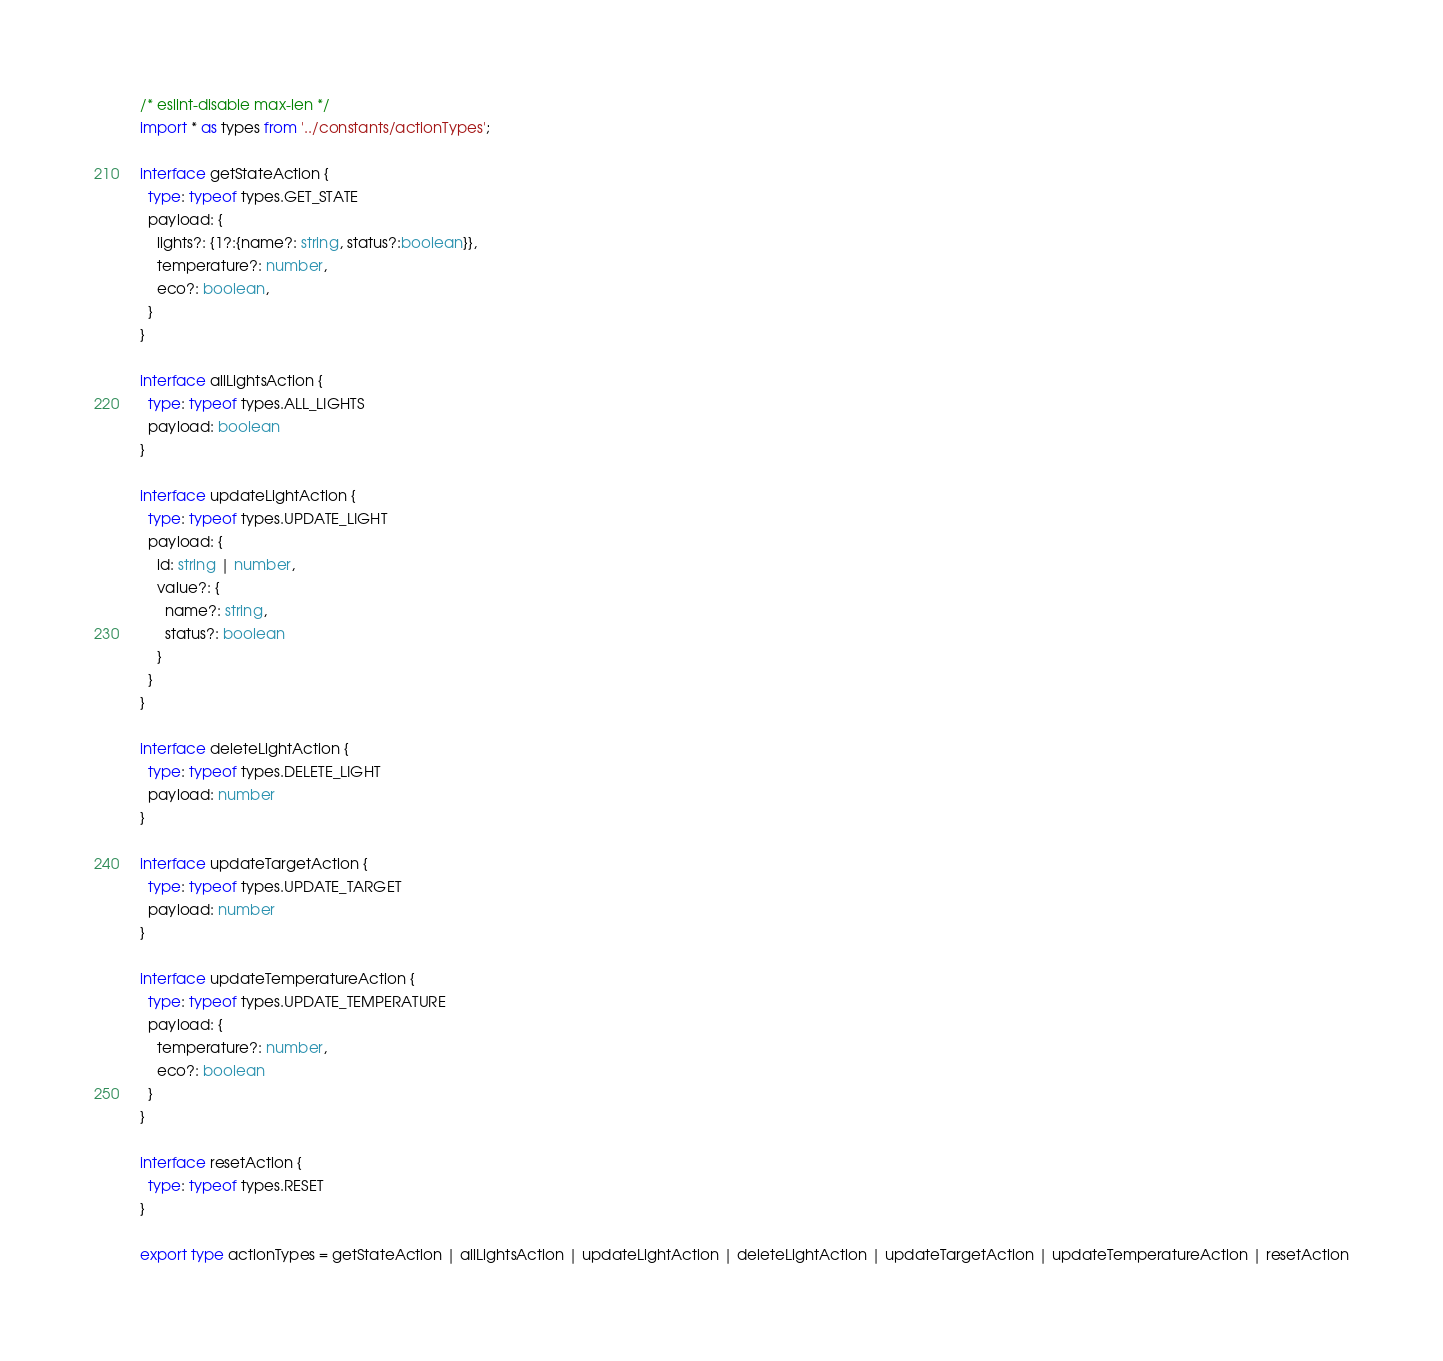Convert code to text. <code><loc_0><loc_0><loc_500><loc_500><_TypeScript_>/* eslint-disable max-len */
import * as types from '../constants/actionTypes';

interface getStateAction {
  type: typeof types.GET_STATE
  payload: {
    lights?: {1?:{name?: string, status?:boolean}},
    temperature?: number,
    eco?: boolean,
  }
}

interface allLightsAction {
  type: typeof types.ALL_LIGHTS
  payload: boolean
}

interface updateLightAction {
  type: typeof types.UPDATE_LIGHT
  payload: {
    id: string | number,
    value?: {
      name?: string,
      status?: boolean
    }
  }
}

interface deleteLightAction {
  type: typeof types.DELETE_LIGHT
  payload: number
}

interface updateTargetAction {
  type: typeof types.UPDATE_TARGET
  payload: number
}

interface updateTemperatureAction {
  type: typeof types.UPDATE_TEMPERATURE
  payload: {
    temperature?: number,
    eco?: boolean
  }
}

interface resetAction {
  type: typeof types.RESET
}

export type actionTypes = getStateAction | allLightsAction | updateLightAction | deleteLightAction | updateTargetAction | updateTemperatureAction | resetAction
</code> 